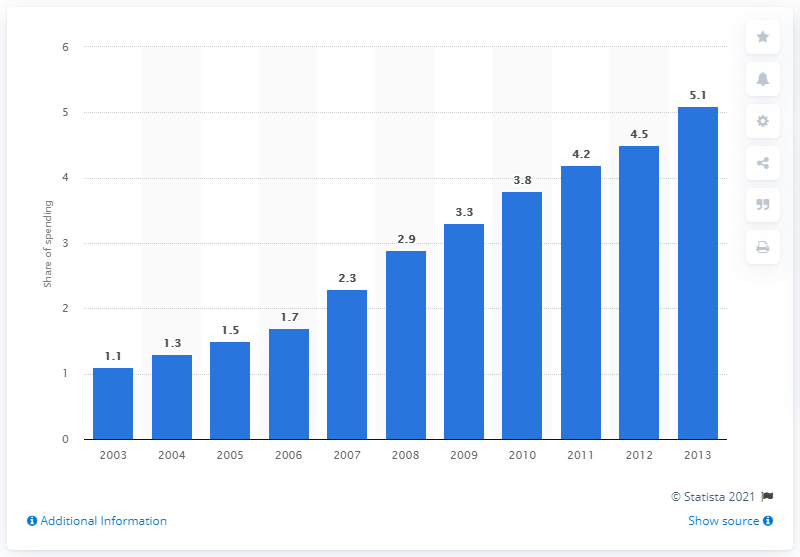Specify some key components in this picture. E-commerce accounted for 5.1% of grocery spending in 2013. 